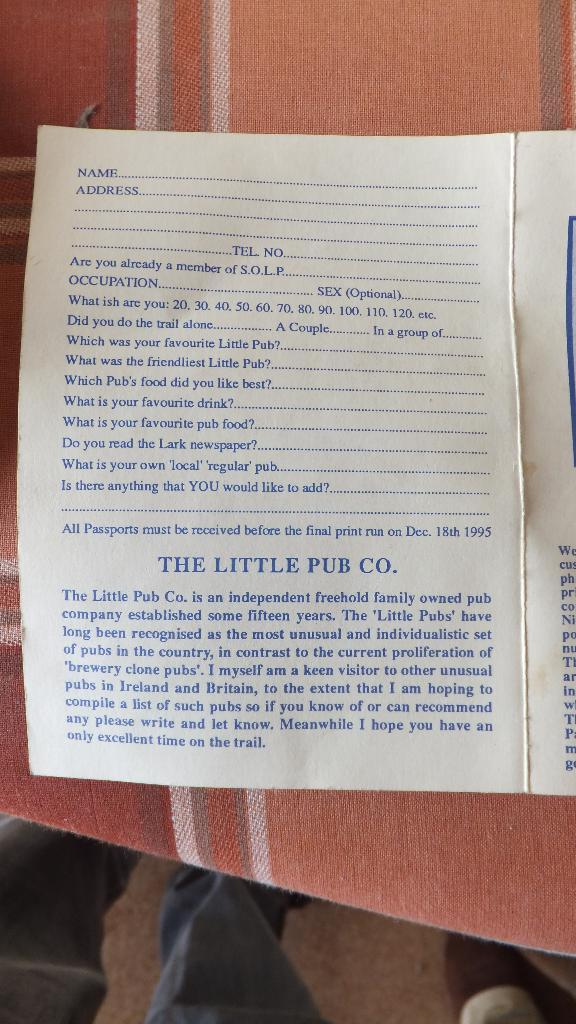What type of object is present on the cloth in the image? There are papers with text in the image. What is the surface on which the papers are placed? The papers are on a cloth. Can you describe any part of a person visible in the image? Yes, there are legs of a person visible at the bottom of the image. What type of steel is used to create the view in the image? There is no steel or view present in the image; it features papers with text on a cloth and legs of a person. 